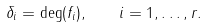<formula> <loc_0><loc_0><loc_500><loc_500>\delta _ { i } = \deg ( f _ { i } ) , \quad i = 1 , \dots , r .</formula> 